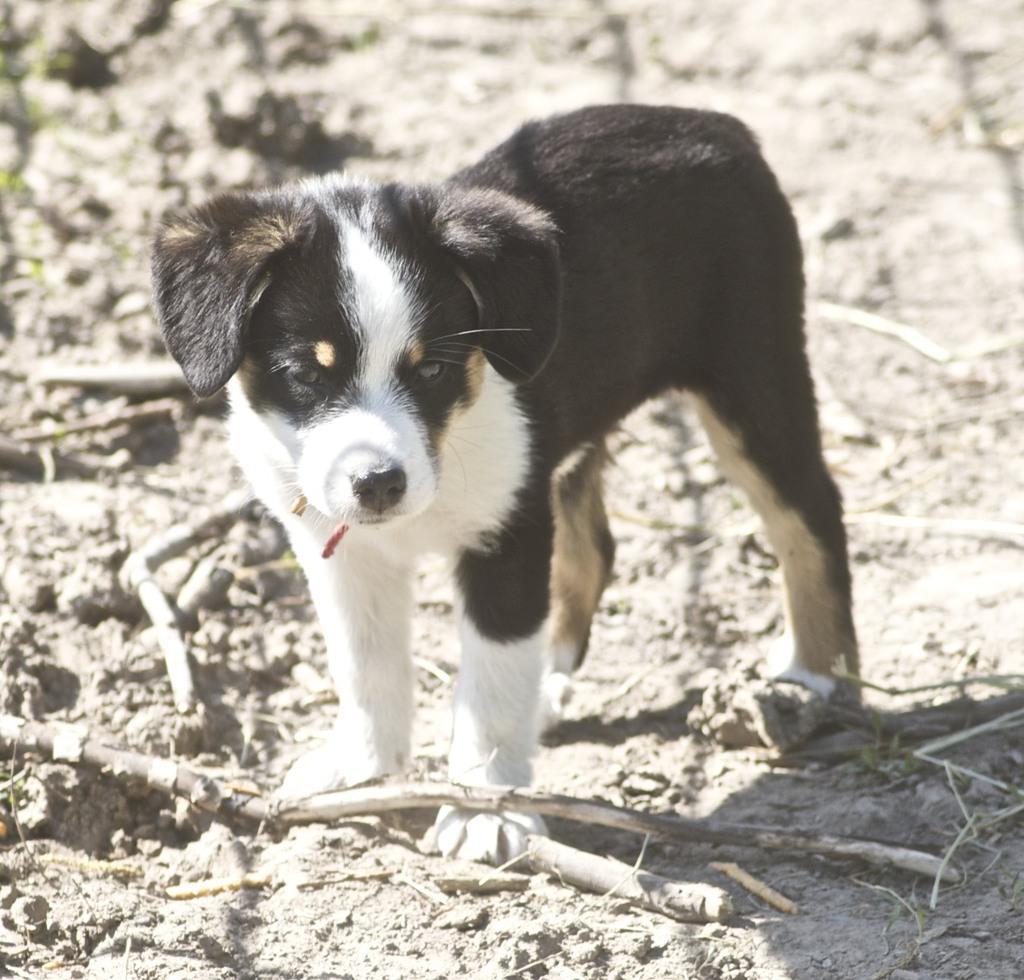Could you give a brief overview of what you see in this image? In this image we can see a dog and there is some wood on the ground. 